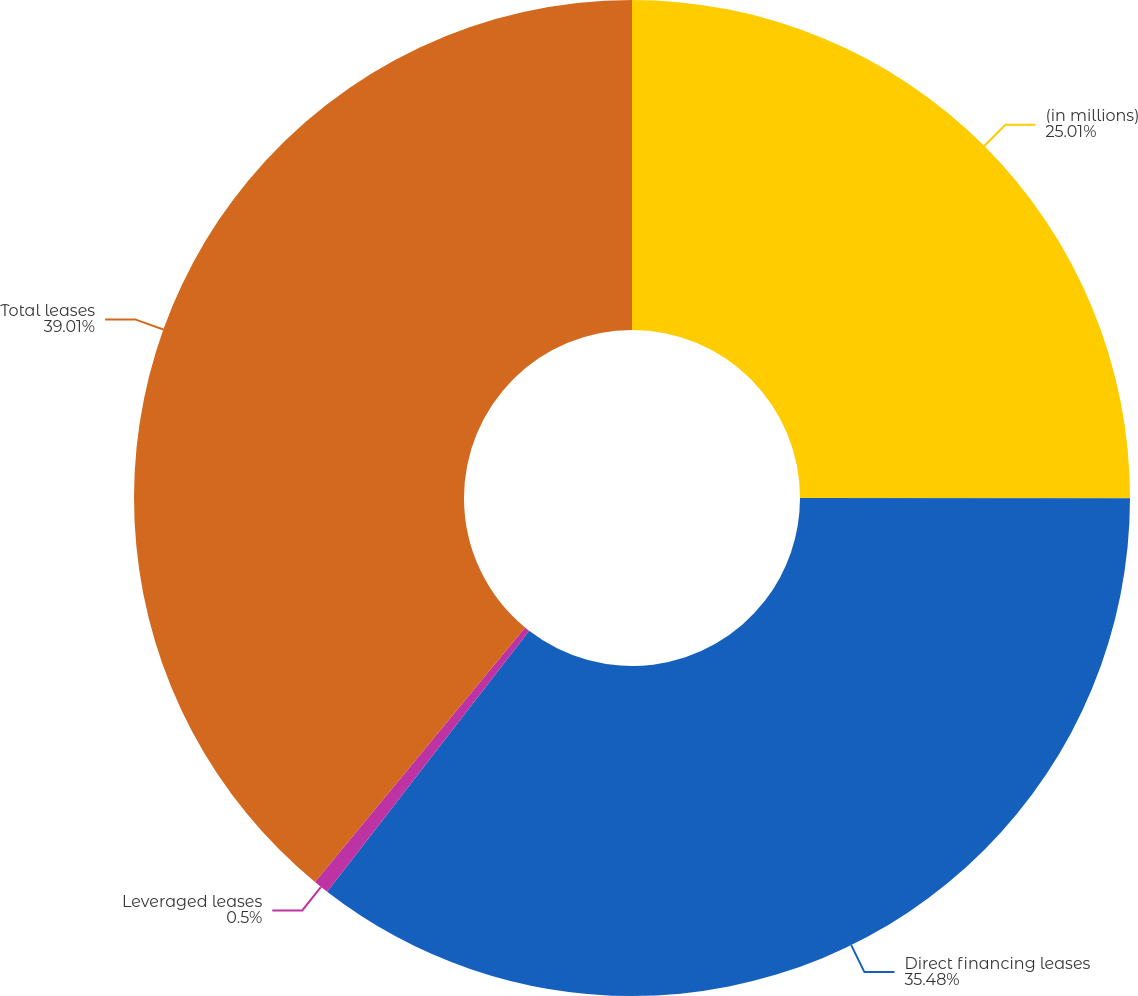<chart> <loc_0><loc_0><loc_500><loc_500><pie_chart><fcel>(in millions)<fcel>Direct financing leases<fcel>Leveraged leases<fcel>Total leases<nl><fcel>25.01%<fcel>35.48%<fcel>0.5%<fcel>39.02%<nl></chart> 